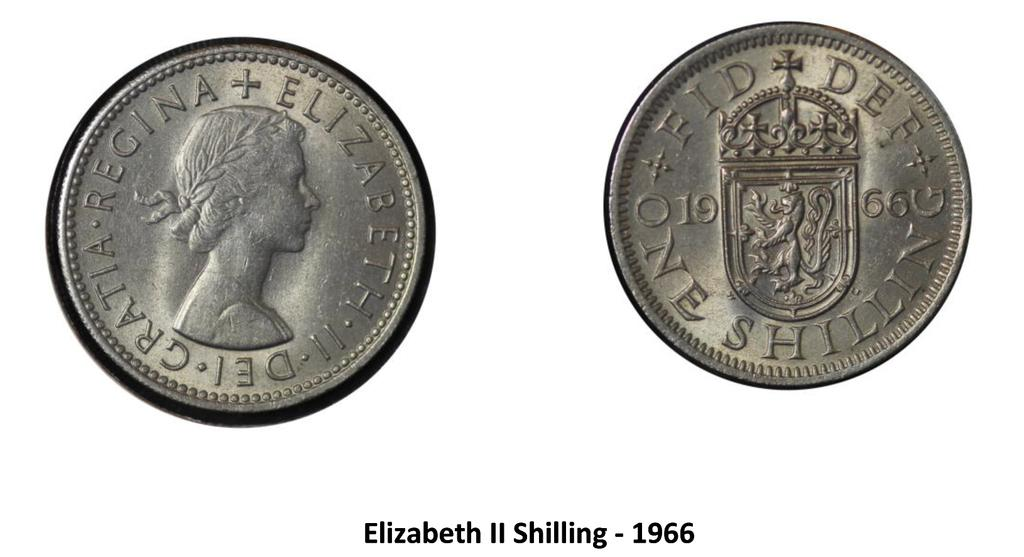Provide a one-sentence caption for the provided image. The front and back of an Eliabeth II Shilling are shown. 